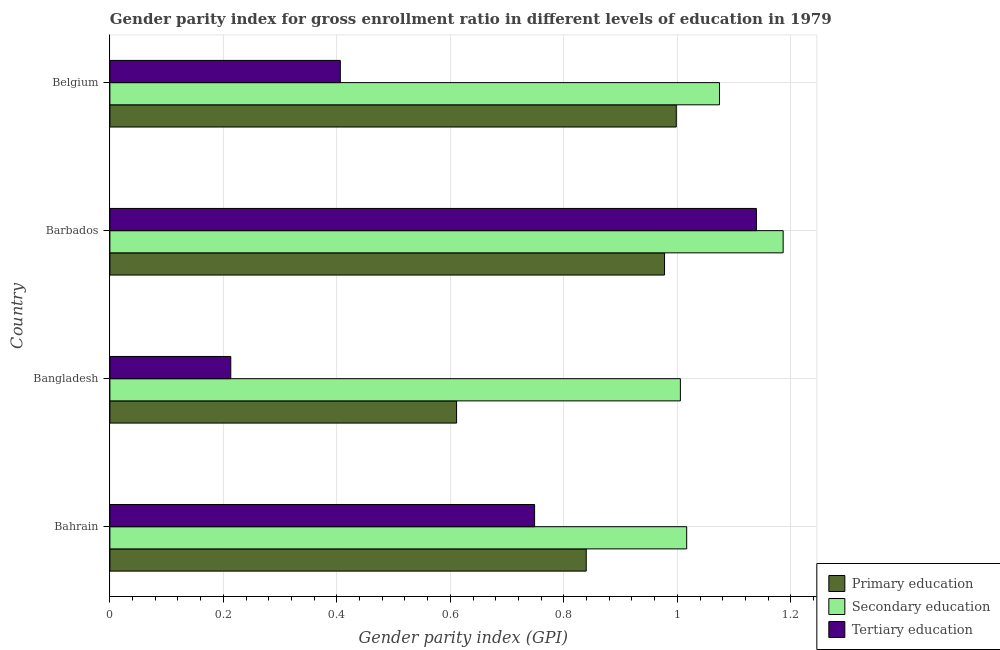Are the number of bars per tick equal to the number of legend labels?
Offer a terse response. Yes. Are the number of bars on each tick of the Y-axis equal?
Give a very brief answer. Yes. How many bars are there on the 1st tick from the top?
Keep it short and to the point. 3. What is the label of the 1st group of bars from the top?
Give a very brief answer. Belgium. In how many cases, is the number of bars for a given country not equal to the number of legend labels?
Offer a terse response. 0. What is the gender parity index in secondary education in Bahrain?
Ensure brevity in your answer.  1.02. Across all countries, what is the maximum gender parity index in secondary education?
Provide a short and direct response. 1.19. Across all countries, what is the minimum gender parity index in tertiary education?
Make the answer very short. 0.21. In which country was the gender parity index in tertiary education maximum?
Your answer should be compact. Barbados. What is the total gender parity index in primary education in the graph?
Keep it short and to the point. 3.43. What is the difference between the gender parity index in secondary education in Bahrain and that in Bangladesh?
Your response must be concise. 0.01. What is the difference between the gender parity index in tertiary education in Belgium and the gender parity index in primary education in Barbados?
Your answer should be compact. -0.57. What is the average gender parity index in secondary education per country?
Make the answer very short. 1.07. What is the difference between the gender parity index in secondary education and gender parity index in tertiary education in Barbados?
Provide a short and direct response. 0.05. In how many countries, is the gender parity index in primary education greater than 0.6000000000000001 ?
Your response must be concise. 4. What is the ratio of the gender parity index in tertiary education in Bahrain to that in Belgium?
Make the answer very short. 1.84. Is the gender parity index in tertiary education in Bahrain less than that in Barbados?
Your answer should be very brief. Yes. What is the difference between the highest and the second highest gender parity index in tertiary education?
Offer a very short reply. 0.39. What is the difference between the highest and the lowest gender parity index in secondary education?
Keep it short and to the point. 0.18. In how many countries, is the gender parity index in primary education greater than the average gender parity index in primary education taken over all countries?
Provide a short and direct response. 2. Is the sum of the gender parity index in tertiary education in Bahrain and Barbados greater than the maximum gender parity index in secondary education across all countries?
Ensure brevity in your answer.  Yes. What does the 1st bar from the top in Bangladesh represents?
Your answer should be very brief. Tertiary education. How many bars are there?
Provide a short and direct response. 12. Are all the bars in the graph horizontal?
Keep it short and to the point. Yes. Are the values on the major ticks of X-axis written in scientific E-notation?
Give a very brief answer. No. What is the title of the graph?
Your answer should be compact. Gender parity index for gross enrollment ratio in different levels of education in 1979. What is the label or title of the X-axis?
Offer a very short reply. Gender parity index (GPI). What is the Gender parity index (GPI) of Primary education in Bahrain?
Keep it short and to the point. 0.84. What is the Gender parity index (GPI) of Secondary education in Bahrain?
Your answer should be compact. 1.02. What is the Gender parity index (GPI) of Tertiary education in Bahrain?
Your answer should be compact. 0.75. What is the Gender parity index (GPI) of Primary education in Bangladesh?
Ensure brevity in your answer.  0.61. What is the Gender parity index (GPI) in Secondary education in Bangladesh?
Keep it short and to the point. 1.01. What is the Gender parity index (GPI) in Tertiary education in Bangladesh?
Your answer should be compact. 0.21. What is the Gender parity index (GPI) in Primary education in Barbados?
Make the answer very short. 0.98. What is the Gender parity index (GPI) in Secondary education in Barbados?
Provide a succinct answer. 1.19. What is the Gender parity index (GPI) of Tertiary education in Barbados?
Give a very brief answer. 1.14. What is the Gender parity index (GPI) in Primary education in Belgium?
Provide a succinct answer. 1. What is the Gender parity index (GPI) of Secondary education in Belgium?
Provide a succinct answer. 1.07. What is the Gender parity index (GPI) of Tertiary education in Belgium?
Make the answer very short. 0.41. Across all countries, what is the maximum Gender parity index (GPI) of Primary education?
Your response must be concise. 1. Across all countries, what is the maximum Gender parity index (GPI) of Secondary education?
Give a very brief answer. 1.19. Across all countries, what is the maximum Gender parity index (GPI) of Tertiary education?
Provide a succinct answer. 1.14. Across all countries, what is the minimum Gender parity index (GPI) in Primary education?
Make the answer very short. 0.61. Across all countries, what is the minimum Gender parity index (GPI) of Secondary education?
Your answer should be compact. 1.01. Across all countries, what is the minimum Gender parity index (GPI) in Tertiary education?
Your answer should be compact. 0.21. What is the total Gender parity index (GPI) of Primary education in the graph?
Provide a short and direct response. 3.43. What is the total Gender parity index (GPI) in Secondary education in the graph?
Offer a very short reply. 4.28. What is the total Gender parity index (GPI) in Tertiary education in the graph?
Give a very brief answer. 2.51. What is the difference between the Gender parity index (GPI) in Primary education in Bahrain and that in Bangladesh?
Your answer should be very brief. 0.23. What is the difference between the Gender parity index (GPI) in Secondary education in Bahrain and that in Bangladesh?
Make the answer very short. 0.01. What is the difference between the Gender parity index (GPI) in Tertiary education in Bahrain and that in Bangladesh?
Provide a short and direct response. 0.54. What is the difference between the Gender parity index (GPI) of Primary education in Bahrain and that in Barbados?
Provide a succinct answer. -0.14. What is the difference between the Gender parity index (GPI) of Secondary education in Bahrain and that in Barbados?
Offer a very short reply. -0.17. What is the difference between the Gender parity index (GPI) of Tertiary education in Bahrain and that in Barbados?
Keep it short and to the point. -0.39. What is the difference between the Gender parity index (GPI) of Primary education in Bahrain and that in Belgium?
Your answer should be compact. -0.16. What is the difference between the Gender parity index (GPI) in Secondary education in Bahrain and that in Belgium?
Provide a short and direct response. -0.06. What is the difference between the Gender parity index (GPI) in Tertiary education in Bahrain and that in Belgium?
Your response must be concise. 0.34. What is the difference between the Gender parity index (GPI) of Primary education in Bangladesh and that in Barbados?
Make the answer very short. -0.37. What is the difference between the Gender parity index (GPI) of Secondary education in Bangladesh and that in Barbados?
Keep it short and to the point. -0.18. What is the difference between the Gender parity index (GPI) in Tertiary education in Bangladesh and that in Barbados?
Provide a short and direct response. -0.93. What is the difference between the Gender parity index (GPI) in Primary education in Bangladesh and that in Belgium?
Make the answer very short. -0.39. What is the difference between the Gender parity index (GPI) in Secondary education in Bangladesh and that in Belgium?
Keep it short and to the point. -0.07. What is the difference between the Gender parity index (GPI) of Tertiary education in Bangladesh and that in Belgium?
Offer a terse response. -0.19. What is the difference between the Gender parity index (GPI) in Primary education in Barbados and that in Belgium?
Your answer should be very brief. -0.02. What is the difference between the Gender parity index (GPI) in Secondary education in Barbados and that in Belgium?
Offer a terse response. 0.11. What is the difference between the Gender parity index (GPI) in Tertiary education in Barbados and that in Belgium?
Offer a very short reply. 0.73. What is the difference between the Gender parity index (GPI) of Primary education in Bahrain and the Gender parity index (GPI) of Secondary education in Bangladesh?
Give a very brief answer. -0.17. What is the difference between the Gender parity index (GPI) in Primary education in Bahrain and the Gender parity index (GPI) in Tertiary education in Bangladesh?
Keep it short and to the point. 0.63. What is the difference between the Gender parity index (GPI) in Secondary education in Bahrain and the Gender parity index (GPI) in Tertiary education in Bangladesh?
Provide a succinct answer. 0.8. What is the difference between the Gender parity index (GPI) of Primary education in Bahrain and the Gender parity index (GPI) of Secondary education in Barbados?
Give a very brief answer. -0.35. What is the difference between the Gender parity index (GPI) in Primary education in Bahrain and the Gender parity index (GPI) in Tertiary education in Barbados?
Your answer should be very brief. -0.3. What is the difference between the Gender parity index (GPI) of Secondary education in Bahrain and the Gender parity index (GPI) of Tertiary education in Barbados?
Provide a short and direct response. -0.12. What is the difference between the Gender parity index (GPI) in Primary education in Bahrain and the Gender parity index (GPI) in Secondary education in Belgium?
Your answer should be very brief. -0.23. What is the difference between the Gender parity index (GPI) of Primary education in Bahrain and the Gender parity index (GPI) of Tertiary education in Belgium?
Give a very brief answer. 0.43. What is the difference between the Gender parity index (GPI) in Secondary education in Bahrain and the Gender parity index (GPI) in Tertiary education in Belgium?
Ensure brevity in your answer.  0.61. What is the difference between the Gender parity index (GPI) of Primary education in Bangladesh and the Gender parity index (GPI) of Secondary education in Barbados?
Your answer should be compact. -0.58. What is the difference between the Gender parity index (GPI) in Primary education in Bangladesh and the Gender parity index (GPI) in Tertiary education in Barbados?
Provide a short and direct response. -0.53. What is the difference between the Gender parity index (GPI) of Secondary education in Bangladesh and the Gender parity index (GPI) of Tertiary education in Barbados?
Provide a succinct answer. -0.13. What is the difference between the Gender parity index (GPI) of Primary education in Bangladesh and the Gender parity index (GPI) of Secondary education in Belgium?
Provide a succinct answer. -0.46. What is the difference between the Gender parity index (GPI) in Primary education in Bangladesh and the Gender parity index (GPI) in Tertiary education in Belgium?
Provide a short and direct response. 0.2. What is the difference between the Gender parity index (GPI) in Secondary education in Bangladesh and the Gender parity index (GPI) in Tertiary education in Belgium?
Offer a very short reply. 0.6. What is the difference between the Gender parity index (GPI) in Primary education in Barbados and the Gender parity index (GPI) in Secondary education in Belgium?
Your answer should be compact. -0.1. What is the difference between the Gender parity index (GPI) of Secondary education in Barbados and the Gender parity index (GPI) of Tertiary education in Belgium?
Provide a succinct answer. 0.78. What is the average Gender parity index (GPI) in Primary education per country?
Keep it short and to the point. 0.86. What is the average Gender parity index (GPI) in Secondary education per country?
Give a very brief answer. 1.07. What is the average Gender parity index (GPI) in Tertiary education per country?
Provide a succinct answer. 0.63. What is the difference between the Gender parity index (GPI) in Primary education and Gender parity index (GPI) in Secondary education in Bahrain?
Provide a short and direct response. -0.18. What is the difference between the Gender parity index (GPI) of Primary education and Gender parity index (GPI) of Tertiary education in Bahrain?
Offer a terse response. 0.09. What is the difference between the Gender parity index (GPI) in Secondary education and Gender parity index (GPI) in Tertiary education in Bahrain?
Your response must be concise. 0.27. What is the difference between the Gender parity index (GPI) of Primary education and Gender parity index (GPI) of Secondary education in Bangladesh?
Offer a very short reply. -0.39. What is the difference between the Gender parity index (GPI) in Primary education and Gender parity index (GPI) in Tertiary education in Bangladesh?
Your response must be concise. 0.4. What is the difference between the Gender parity index (GPI) of Secondary education and Gender parity index (GPI) of Tertiary education in Bangladesh?
Keep it short and to the point. 0.79. What is the difference between the Gender parity index (GPI) in Primary education and Gender parity index (GPI) in Secondary education in Barbados?
Your response must be concise. -0.21. What is the difference between the Gender parity index (GPI) in Primary education and Gender parity index (GPI) in Tertiary education in Barbados?
Offer a very short reply. -0.16. What is the difference between the Gender parity index (GPI) of Secondary education and Gender parity index (GPI) of Tertiary education in Barbados?
Offer a terse response. 0.05. What is the difference between the Gender parity index (GPI) in Primary education and Gender parity index (GPI) in Secondary education in Belgium?
Your answer should be very brief. -0.08. What is the difference between the Gender parity index (GPI) of Primary education and Gender parity index (GPI) of Tertiary education in Belgium?
Give a very brief answer. 0.59. What is the difference between the Gender parity index (GPI) in Secondary education and Gender parity index (GPI) in Tertiary education in Belgium?
Keep it short and to the point. 0.67. What is the ratio of the Gender parity index (GPI) of Primary education in Bahrain to that in Bangladesh?
Your answer should be compact. 1.37. What is the ratio of the Gender parity index (GPI) of Secondary education in Bahrain to that in Bangladesh?
Give a very brief answer. 1.01. What is the ratio of the Gender parity index (GPI) in Tertiary education in Bahrain to that in Bangladesh?
Make the answer very short. 3.51. What is the ratio of the Gender parity index (GPI) of Primary education in Bahrain to that in Barbados?
Your answer should be compact. 0.86. What is the ratio of the Gender parity index (GPI) in Secondary education in Bahrain to that in Barbados?
Your response must be concise. 0.86. What is the ratio of the Gender parity index (GPI) of Tertiary education in Bahrain to that in Barbados?
Offer a very short reply. 0.66. What is the ratio of the Gender parity index (GPI) in Primary education in Bahrain to that in Belgium?
Your answer should be very brief. 0.84. What is the ratio of the Gender parity index (GPI) of Secondary education in Bahrain to that in Belgium?
Your answer should be very brief. 0.95. What is the ratio of the Gender parity index (GPI) of Tertiary education in Bahrain to that in Belgium?
Provide a succinct answer. 1.84. What is the ratio of the Gender parity index (GPI) in Primary education in Bangladesh to that in Barbados?
Ensure brevity in your answer.  0.62. What is the ratio of the Gender parity index (GPI) in Secondary education in Bangladesh to that in Barbados?
Keep it short and to the point. 0.85. What is the ratio of the Gender parity index (GPI) of Tertiary education in Bangladesh to that in Barbados?
Provide a succinct answer. 0.19. What is the ratio of the Gender parity index (GPI) in Primary education in Bangladesh to that in Belgium?
Your response must be concise. 0.61. What is the ratio of the Gender parity index (GPI) in Secondary education in Bangladesh to that in Belgium?
Offer a terse response. 0.94. What is the ratio of the Gender parity index (GPI) in Tertiary education in Bangladesh to that in Belgium?
Give a very brief answer. 0.52. What is the ratio of the Gender parity index (GPI) in Primary education in Barbados to that in Belgium?
Offer a terse response. 0.98. What is the ratio of the Gender parity index (GPI) in Secondary education in Barbados to that in Belgium?
Offer a very short reply. 1.1. What is the ratio of the Gender parity index (GPI) of Tertiary education in Barbados to that in Belgium?
Offer a very short reply. 2.81. What is the difference between the highest and the second highest Gender parity index (GPI) in Primary education?
Offer a terse response. 0.02. What is the difference between the highest and the second highest Gender parity index (GPI) of Secondary education?
Keep it short and to the point. 0.11. What is the difference between the highest and the second highest Gender parity index (GPI) of Tertiary education?
Your response must be concise. 0.39. What is the difference between the highest and the lowest Gender parity index (GPI) of Primary education?
Your answer should be very brief. 0.39. What is the difference between the highest and the lowest Gender parity index (GPI) of Secondary education?
Provide a succinct answer. 0.18. What is the difference between the highest and the lowest Gender parity index (GPI) of Tertiary education?
Your answer should be compact. 0.93. 